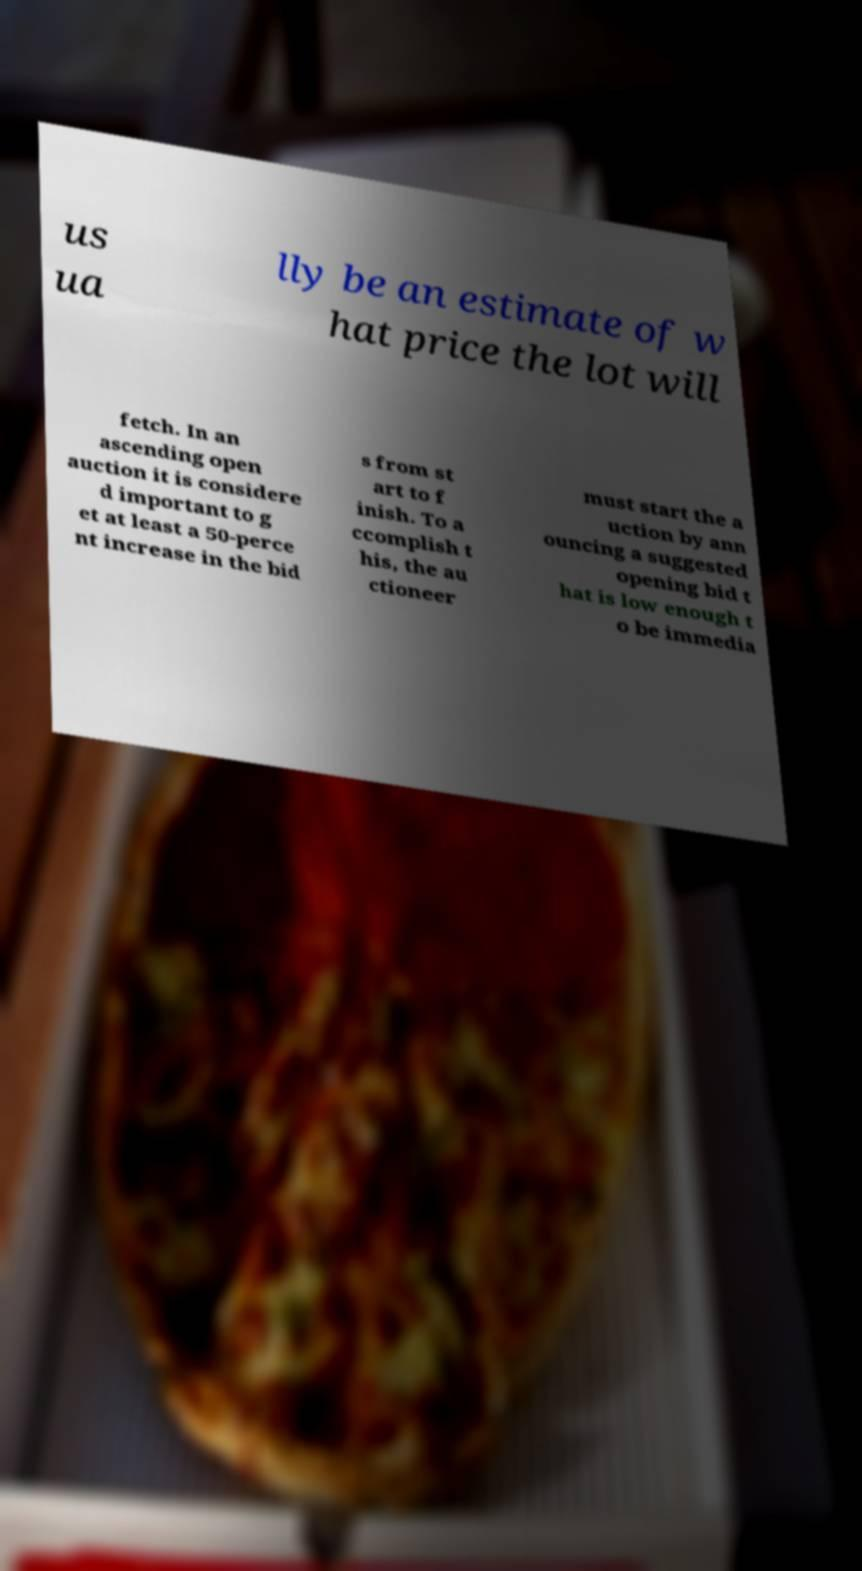Please identify and transcribe the text found in this image. us ua lly be an estimate of w hat price the lot will fetch. In an ascending open auction it is considere d important to g et at least a 50-perce nt increase in the bid s from st art to f inish. To a ccomplish t his, the au ctioneer must start the a uction by ann ouncing a suggested opening bid t hat is low enough t o be immedia 